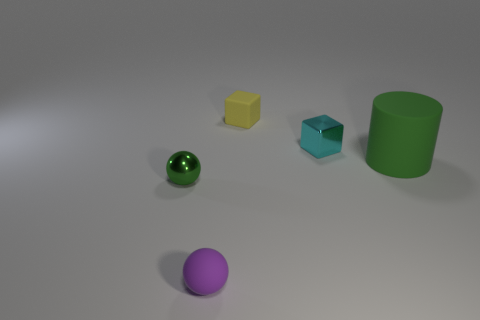Add 4 small cyan metallic things. How many objects exist? 9 Subtract all cubes. How many objects are left? 3 Add 1 small purple spheres. How many small purple spheres are left? 2 Add 5 purple rubber balls. How many purple rubber balls exist? 6 Subtract 0 brown spheres. How many objects are left? 5 Subtract all small metallic things. Subtract all small yellow things. How many objects are left? 2 